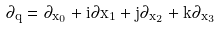<formula> <loc_0><loc_0><loc_500><loc_500>\partial _ { \bar { q } } = \partial _ { x _ { 0 } } + i \partial { x _ { 1 } } + j \partial _ { x _ { 2 } } + k \partial _ { x _ { 3 } }</formula> 